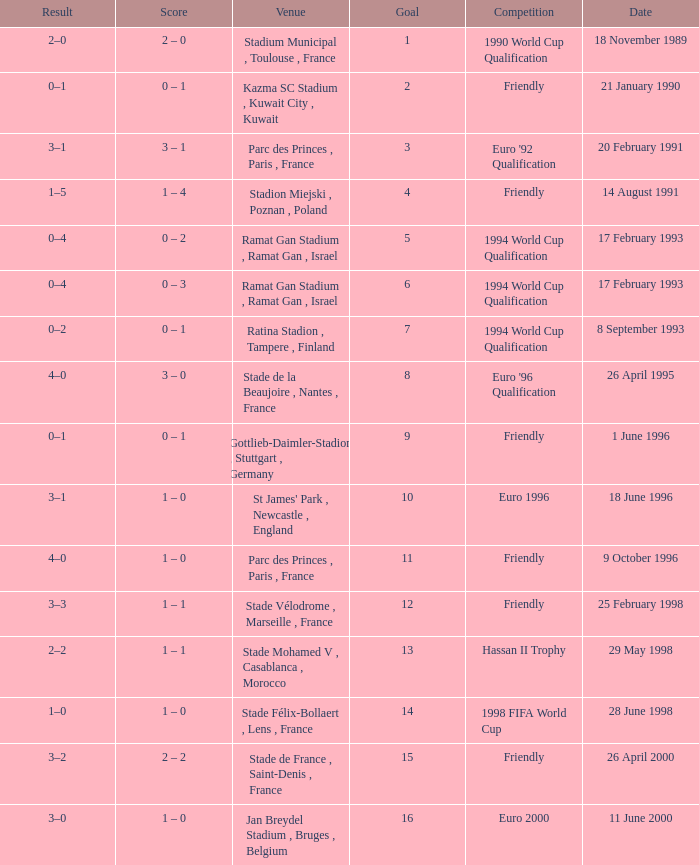What was the date of the game with a result of 3–2? 26 April 2000. 